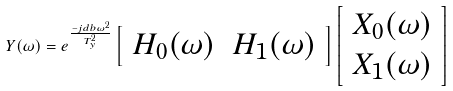<formula> <loc_0><loc_0><loc_500><loc_500>Y ( \omega ) = e ^ { \frac { - j d b \omega ^ { 2 } } { T _ { y } ^ { 2 } } } \left [ \begin{array} { l l } H _ { 0 } ( \omega ) & H _ { 1 } ( \omega ) \end{array} \right ] \left [ \begin{array} { l } X _ { 0 } ( \omega ) \\ X _ { 1 } ( \omega ) \end{array} \right ]</formula> 